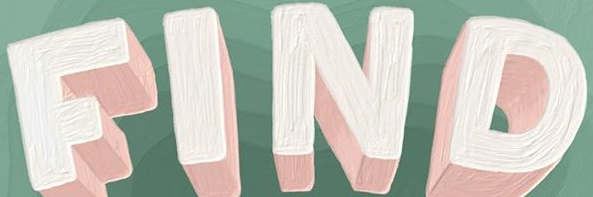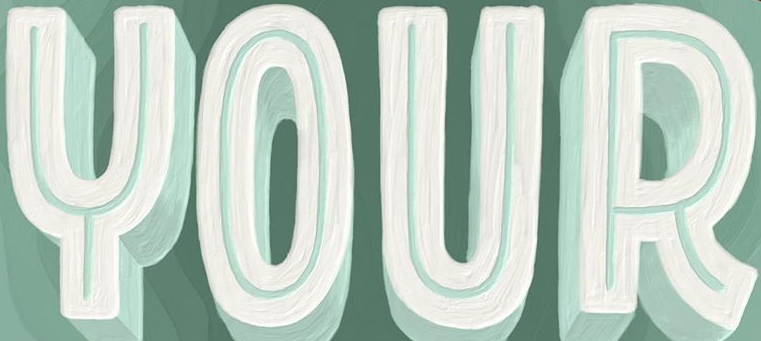Transcribe the words shown in these images in order, separated by a semicolon. FIND; YOUR 